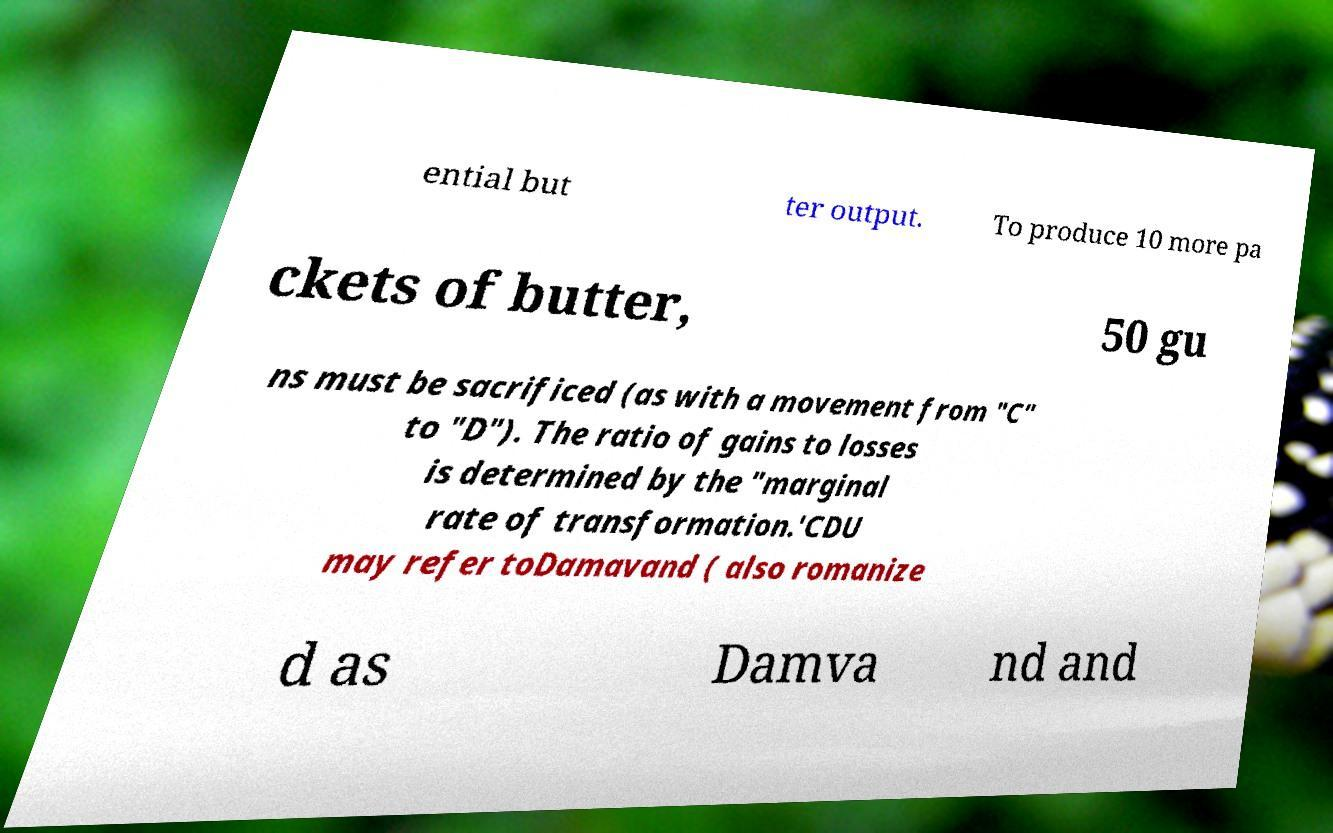Please read and relay the text visible in this image. What does it say? ential but ter output. To produce 10 more pa ckets of butter, 50 gu ns must be sacrificed (as with a movement from "C" to "D"). The ratio of gains to losses is determined by the "marginal rate of transformation.'CDU may refer toDamavand ( also romanize d as Damva nd and 